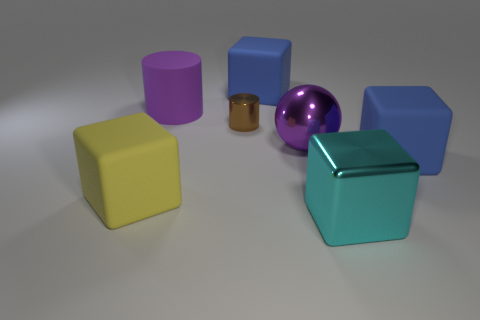Are there any other things that have the same size as the brown thing?
Make the answer very short. No. Are the purple thing in front of the tiny brown shiny object and the large purple thing that is behind the purple shiny object made of the same material?
Offer a terse response. No. Are there more tiny brown metal cylinders than tiny brown cubes?
Keep it short and to the point. Yes. Are there any other things of the same color as the metallic ball?
Offer a terse response. Yes. Do the large purple cylinder and the big purple sphere have the same material?
Offer a terse response. No. Are there fewer small brown metallic cylinders than tiny cyan balls?
Your answer should be compact. No. Does the big purple metal object have the same shape as the small shiny object?
Provide a succinct answer. No. What color is the large ball?
Your response must be concise. Purple. How many other objects are the same material as the cyan thing?
Offer a very short reply. 2. What number of red things are either small shiny objects or small rubber cylinders?
Your response must be concise. 0. 